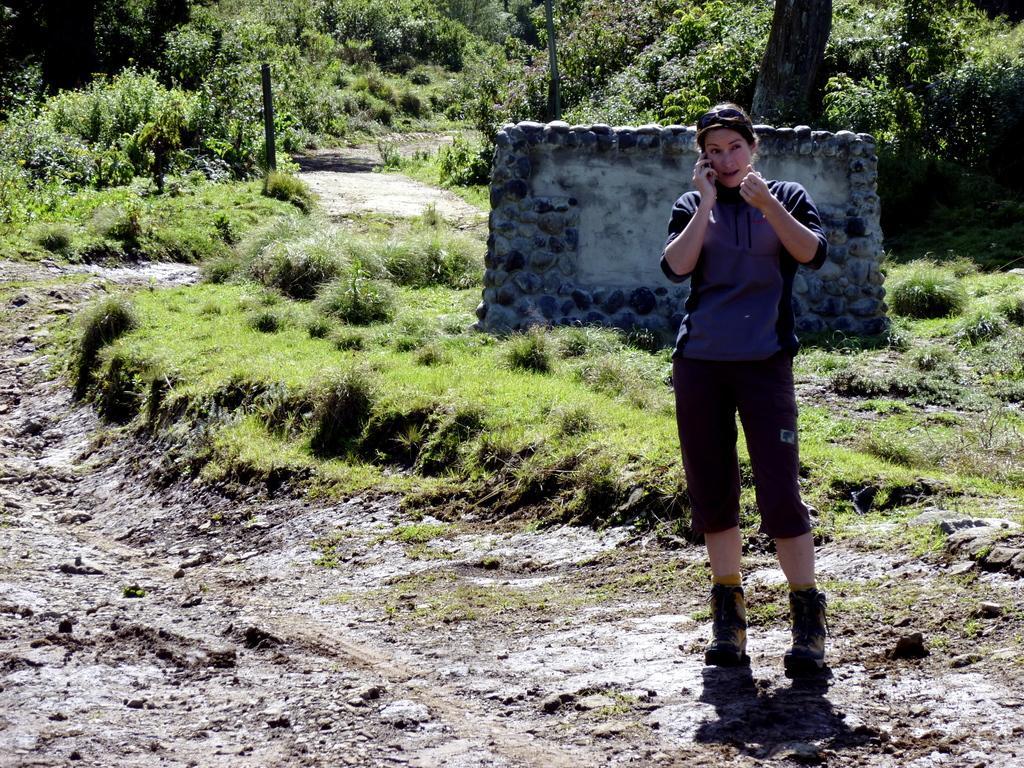In one or two sentences, can you explain what this image depicts? In the foreground of the picture there is soil and a woman standing. In the center of the picture there are shrubs, grass and a construction. In the background there are trees, plants, grass and shrubs. 